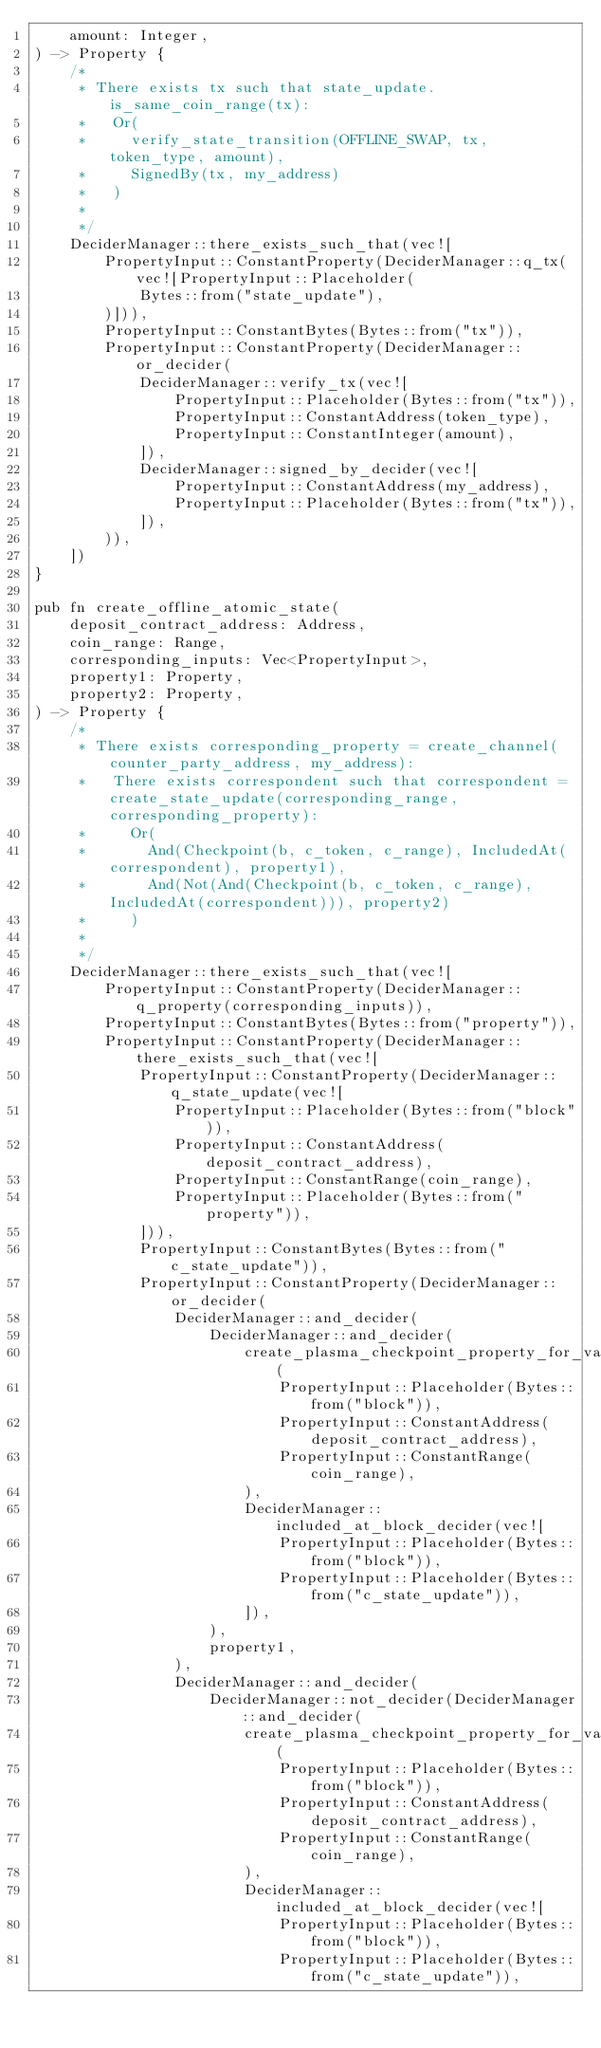Convert code to text. <code><loc_0><loc_0><loc_500><loc_500><_Rust_>    amount: Integer,
) -> Property {
    /*
     * There exists tx such that state_update.is_same_coin_range(tx):
     *   Or(
     *     verify_state_transition(OFFLINE_SWAP, tx, token_type, amount),
     *     SignedBy(tx, my_address)
     *   )
     *
     */
    DeciderManager::there_exists_such_that(vec![
        PropertyInput::ConstantProperty(DeciderManager::q_tx(vec![PropertyInput::Placeholder(
            Bytes::from("state_update"),
        )])),
        PropertyInput::ConstantBytes(Bytes::from("tx")),
        PropertyInput::ConstantProperty(DeciderManager::or_decider(
            DeciderManager::verify_tx(vec![
                PropertyInput::Placeholder(Bytes::from("tx")),
                PropertyInput::ConstantAddress(token_type),
                PropertyInput::ConstantInteger(amount),
            ]),
            DeciderManager::signed_by_decider(vec![
                PropertyInput::ConstantAddress(my_address),
                PropertyInput::Placeholder(Bytes::from("tx")),
            ]),
        )),
    ])
}

pub fn create_offline_atomic_state(
    deposit_contract_address: Address,
    coin_range: Range,
    corresponding_inputs: Vec<PropertyInput>,
    property1: Property,
    property2: Property,
) -> Property {
    /*
     * There exists corresponding_property = create_channel(counter_party_address, my_address):
     *   There exists correspondent such that correspondent = create_state_update(corresponding_range, corresponding_property):
     *     Or(
     *       And(Checkpoint(b, c_token, c_range), IncludedAt(correspondent), property1),
     *       And(Not(And(Checkpoint(b, c_token, c_range), IncludedAt(correspondent))), property2)
     *     )
     *
     */
    DeciderManager::there_exists_such_that(vec![
        PropertyInput::ConstantProperty(DeciderManager::q_property(corresponding_inputs)),
        PropertyInput::ConstantBytes(Bytes::from("property")),
        PropertyInput::ConstantProperty(DeciderManager::there_exists_such_that(vec![
            PropertyInput::ConstantProperty(DeciderManager::q_state_update(vec![
                PropertyInput::Placeholder(Bytes::from("block")),
                PropertyInput::ConstantAddress(deposit_contract_address),
                PropertyInput::ConstantRange(coin_range),
                PropertyInput::Placeholder(Bytes::from("property")),
            ])),
            PropertyInput::ConstantBytes(Bytes::from("c_state_update")),
            PropertyInput::ConstantProperty(DeciderManager::or_decider(
                DeciderManager::and_decider(
                    DeciderManager::and_decider(
                        create_plasma_checkpoint_property_for_variables(
                            PropertyInput::Placeholder(Bytes::from("block")),
                            PropertyInput::ConstantAddress(deposit_contract_address),
                            PropertyInput::ConstantRange(coin_range),
                        ),
                        DeciderManager::included_at_block_decider(vec![
                            PropertyInput::Placeholder(Bytes::from("block")),
                            PropertyInput::Placeholder(Bytes::from("c_state_update")),
                        ]),
                    ),
                    property1,
                ),
                DeciderManager::and_decider(
                    DeciderManager::not_decider(DeciderManager::and_decider(
                        create_plasma_checkpoint_property_for_variables(
                            PropertyInput::Placeholder(Bytes::from("block")),
                            PropertyInput::ConstantAddress(deposit_contract_address),
                            PropertyInput::ConstantRange(coin_range),
                        ),
                        DeciderManager::included_at_block_decider(vec![
                            PropertyInput::Placeholder(Bytes::from("block")),
                            PropertyInput::Placeholder(Bytes::from("c_state_update")),</code> 